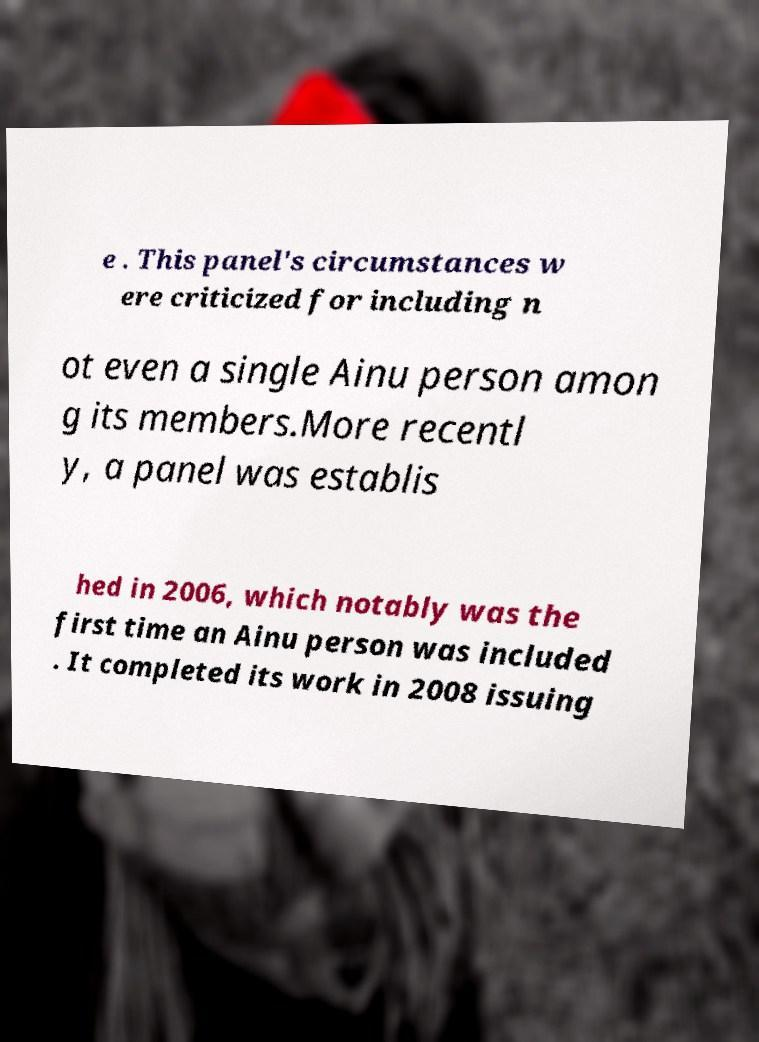For documentation purposes, I need the text within this image transcribed. Could you provide that? e . This panel's circumstances w ere criticized for including n ot even a single Ainu person amon g its members.More recentl y, a panel was establis hed in 2006, which notably was the first time an Ainu person was included . It completed its work in 2008 issuing 